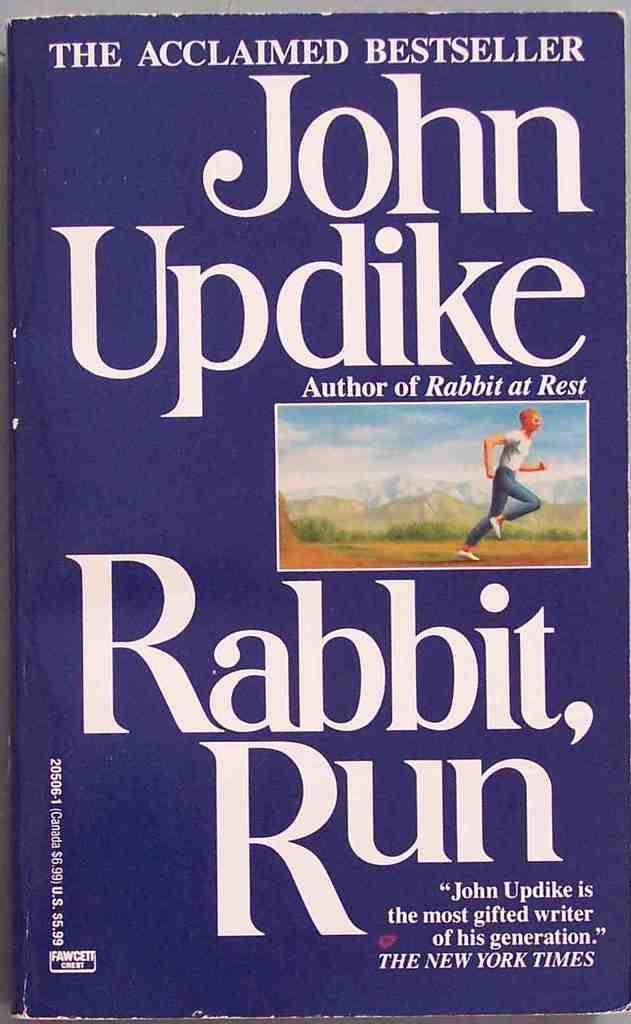Who wrote this book?
Offer a terse response. John updike. 